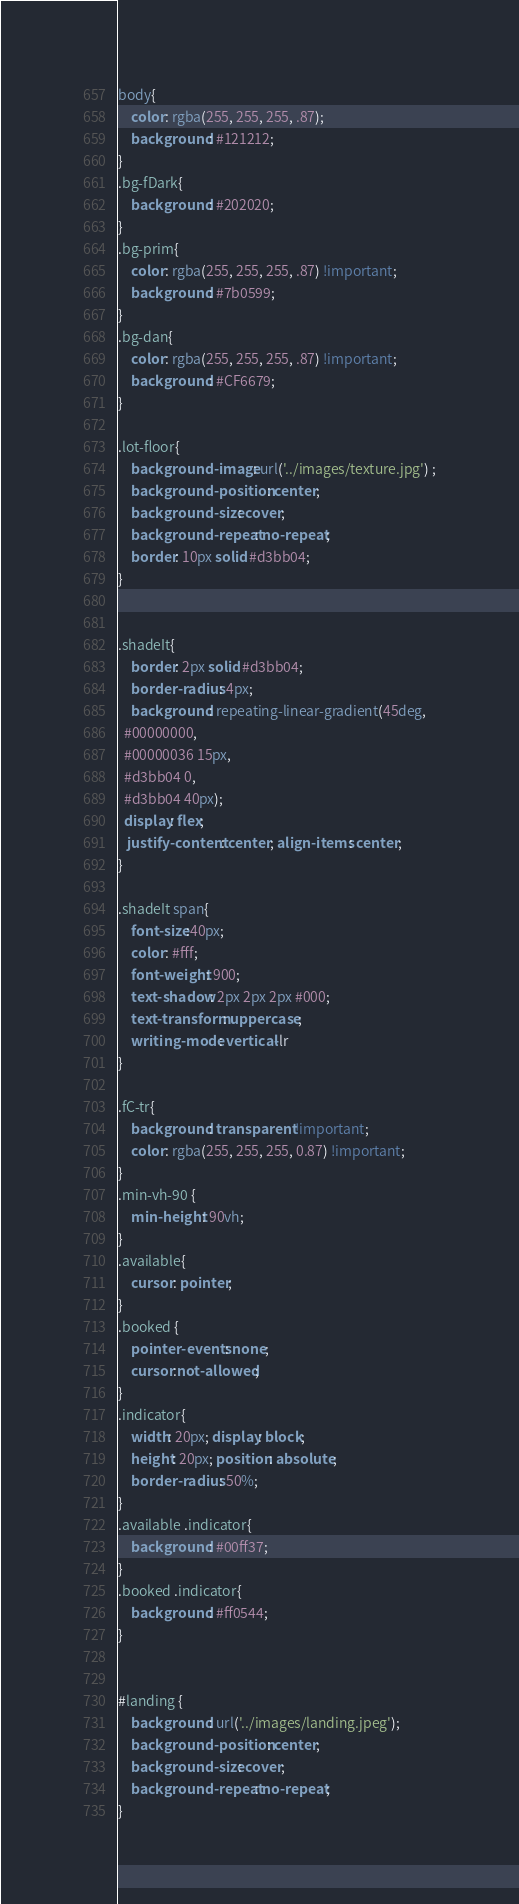Convert code to text. <code><loc_0><loc_0><loc_500><loc_500><_CSS_>body{
    color: rgba(255, 255, 255, .87);
    background: #121212;
}
.bg-fDark{
    background: #202020;
}
.bg-prim{
    color: rgba(255, 255, 255, .87) !important;
    background: #7b0599;
}
.bg-dan{
    color: rgba(255, 255, 255, .87) !important;
    background: #CF6679;
}

.lot-floor{
    background-image: url('../images/texture.jpg') ;
    background-position: center;
    background-size: cover;
    background-repeat: no-repeat;
    border: 10px solid #d3bb04;
}


.shadeIt{
    border: 2px solid #d3bb04;
    border-radius: 4px;
    background: repeating-linear-gradient(45deg,
  #00000000,
  #00000036 15px,
  #d3bb04 0,
  #d3bb04 40px);
  display: flex;
   justify-content: center; align-items: center;
}

.shadeIt span{
    font-size:40px;
    color: #fff;
    font-weight: 900;
    text-shadow: 2px 2px 2px #000;
    text-transform: uppercase;
    writing-mode: vertical-lr   
}

.fC-tr{
    background: transparent !important;
    color: rgba(255, 255, 255, 0.87) !important;
}
.min-vh-90 {
    min-height: 90vh;
}
.available{
    cursor: pointer;
}
.booked {
    pointer-events: none;
    cursor:not-allowed;
}
.indicator{
    width: 20px; display: block;
    height: 20px; position: absolute;
    border-radius: 50%;
}
.available .indicator{
    background: #00ff37;
}
.booked .indicator{
    background: #ff0544;
}


#landing {
    background: url('../images/landing.jpeg');
    background-position: center;
    background-size: cover;
    background-repeat: no-repeat;
}</code> 